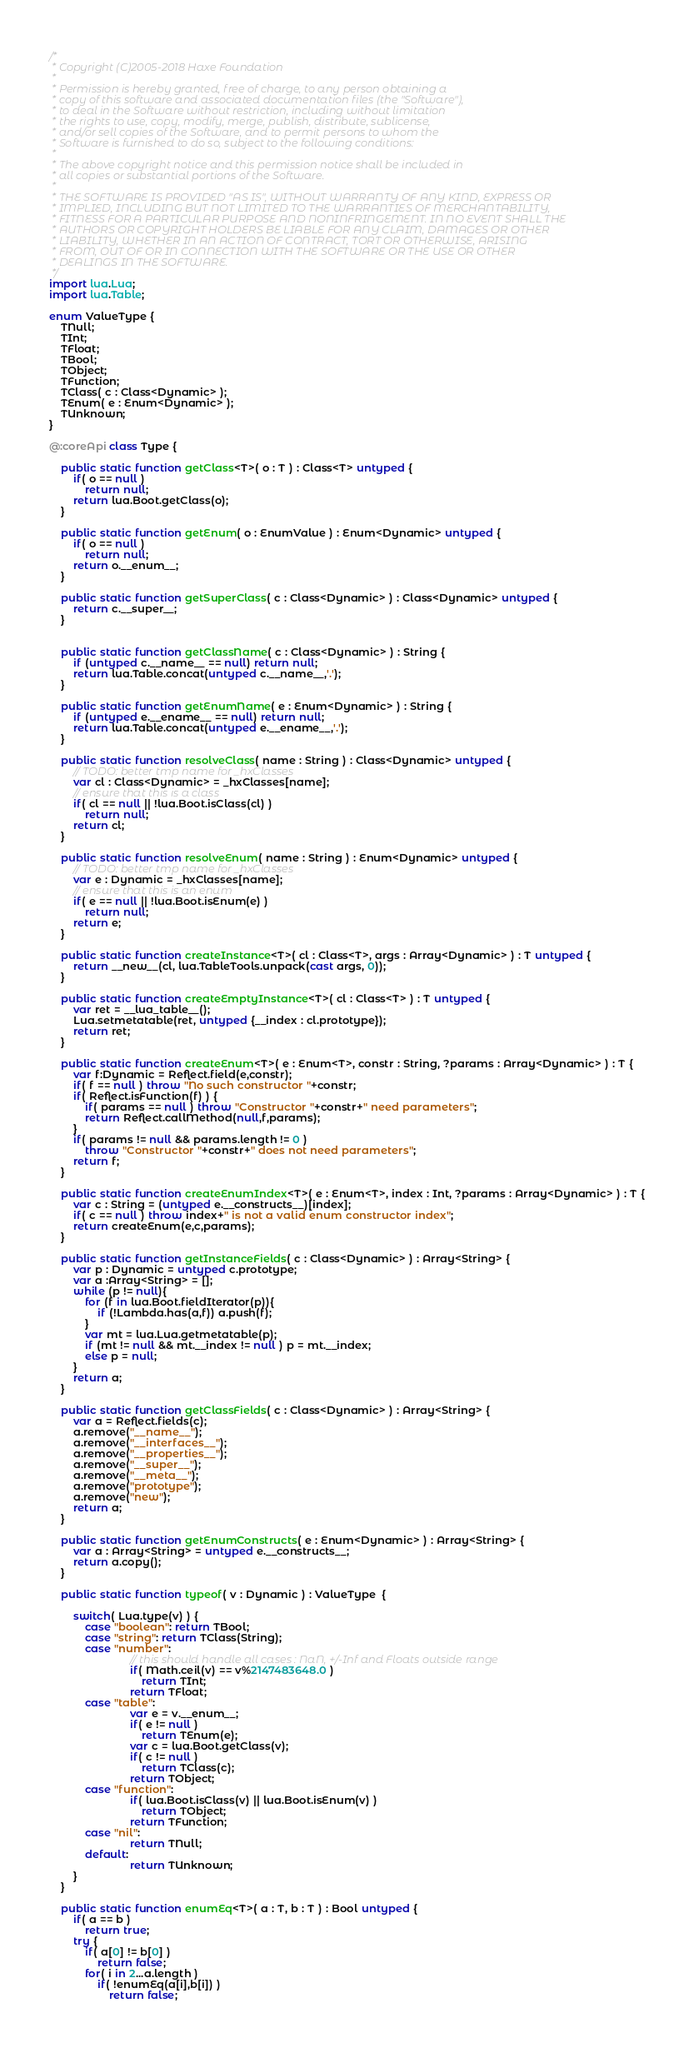<code> <loc_0><loc_0><loc_500><loc_500><_Haxe_>/*
 * Copyright (C)2005-2018 Haxe Foundation
 *
 * Permission is hereby granted, free of charge, to any person obtaining a
 * copy of this software and associated documentation files (the "Software"),
 * to deal in the Software without restriction, including without limitation
 * the rights to use, copy, modify, merge, publish, distribute, sublicense,
 * and/or sell copies of the Software, and to permit persons to whom the
 * Software is furnished to do so, subject to the following conditions:
 *
 * The above copyright notice and this permission notice shall be included in
 * all copies or substantial portions of the Software.
 *
 * THE SOFTWARE IS PROVIDED "AS IS", WITHOUT WARRANTY OF ANY KIND, EXPRESS OR
 * IMPLIED, INCLUDING BUT NOT LIMITED TO THE WARRANTIES OF MERCHANTABILITY,
 * FITNESS FOR A PARTICULAR PURPOSE AND NONINFRINGEMENT. IN NO EVENT SHALL THE
 * AUTHORS OR COPYRIGHT HOLDERS BE LIABLE FOR ANY CLAIM, DAMAGES OR OTHER
 * LIABILITY, WHETHER IN AN ACTION OF CONTRACT, TORT OR OTHERWISE, ARISING
 * FROM, OUT OF OR IN CONNECTION WITH THE SOFTWARE OR THE USE OR OTHER
 * DEALINGS IN THE SOFTWARE.
 */
import lua.Lua;
import lua.Table;

enum ValueType {
	TNull;
	TInt;
	TFloat;
	TBool;
	TObject;
	TFunction;
	TClass( c : Class<Dynamic> );
	TEnum( e : Enum<Dynamic> );
	TUnknown;
}

@:coreApi class Type {

	public static function getClass<T>( o : T ) : Class<T> untyped {
		if( o == null )
			return null;
		return lua.Boot.getClass(o);
	}

	public static function getEnum( o : EnumValue ) : Enum<Dynamic> untyped {
		if( o == null )
			return null;
		return o.__enum__;
	}

	public static function getSuperClass( c : Class<Dynamic> ) : Class<Dynamic> untyped {
		return c.__super__;
	}


	public static function getClassName( c : Class<Dynamic> ) : String {
		if (untyped c.__name__ == null) return null;
		return lua.Table.concat(untyped c.__name__,'.');
	}

	public static function getEnumName( e : Enum<Dynamic> ) : String {
		if (untyped e.__ename__ == null) return null;
		return lua.Table.concat(untyped e.__ename__,'.');
	}

	public static function resolveClass( name : String ) : Class<Dynamic> untyped {
		// TODO: better tmp name for _hxClasses
		var cl : Class<Dynamic> = _hxClasses[name];
		// ensure that this is a class
		if( cl == null || !lua.Boot.isClass(cl) )
			return null;
		return cl;
	}

	public static function resolveEnum( name : String ) : Enum<Dynamic> untyped {
		// TODO: better tmp name for _hxClasses
		var e : Dynamic = _hxClasses[name];
		// ensure that this is an enum
		if( e == null || !lua.Boot.isEnum(e) )
			return null;
		return e;
	}

	public static function createInstance<T>( cl : Class<T>, args : Array<Dynamic> ) : T untyped {
		return __new__(cl, lua.TableTools.unpack(cast args, 0));
	}

	public static function createEmptyInstance<T>( cl : Class<T> ) : T untyped {
		var ret = __lua_table__();
		Lua.setmetatable(ret, untyped {__index : cl.prototype});
		return ret;
	}

	public static function createEnum<T>( e : Enum<T>, constr : String, ?params : Array<Dynamic> ) : T {
		var f:Dynamic = Reflect.field(e,constr);
		if( f == null ) throw "No such constructor "+constr;
		if( Reflect.isFunction(f) ) {
			if( params == null ) throw "Constructor "+constr+" need parameters";
			return Reflect.callMethod(null,f,params);
		}
		if( params != null && params.length != 0 )
			throw "Constructor "+constr+" does not need parameters";
		return f;
	}

	public static function createEnumIndex<T>( e : Enum<T>, index : Int, ?params : Array<Dynamic> ) : T {
		var c : String = (untyped e.__constructs__)[index];
		if( c == null ) throw index+" is not a valid enum constructor index";
		return createEnum(e,c,params);
	}

	public static function getInstanceFields( c : Class<Dynamic> ) : Array<String> {
		var p : Dynamic = untyped c.prototype;
		var a :Array<String> = [];
		while (p != null){
			for (f in lua.Boot.fieldIterator(p)){
				if (!Lambda.has(a,f)) a.push(f);
			}
			var mt = lua.Lua.getmetatable(p);
			if (mt != null && mt.__index != null ) p = mt.__index;
			else p = null;
		}
		return a;
	}

	public static function getClassFields( c : Class<Dynamic> ) : Array<String> {
		var a = Reflect.fields(c);
		a.remove("__name__");
		a.remove("__interfaces__");
		a.remove("__properties__");
		a.remove("__super__");
		a.remove("__meta__");
		a.remove("prototype");
		a.remove("new");
		return a;
	}

	public static function getEnumConstructs( e : Enum<Dynamic> ) : Array<String> {
		var a : Array<String> = untyped e.__constructs__;
		return a.copy();
	}

	public static function typeof( v : Dynamic ) : ValueType  {

		switch( Lua.type(v) ) {
			case "boolean": return TBool;
			case "string": return TClass(String);
			case "number":
						   // this should handle all cases : NaN, +/-Inf and Floats outside range
						   if( Math.ceil(v) == v%2147483648.0 )
							   return TInt;
						   return TFloat;
			case "table":
						   var e = v.__enum__;
						   if( e != null )
							   return TEnum(e);
						   var c = lua.Boot.getClass(v);
						   if( c != null )
							   return TClass(c);
						   return TObject;
			case "function":
						   if( lua.Boot.isClass(v) || lua.Boot.isEnum(v) )
							   return TObject;
						   return TFunction;
			case "nil":
						   return TNull;
			default:
						   return TUnknown;
		}
	}

	public static function enumEq<T>( a : T, b : T ) : Bool untyped {
		if( a == b )
			return true;
		try {
			if( a[0] != b[0] )
				return false;
			for( i in 2...a.length )
				if( !enumEq(a[i],b[i]) )
					return false;</code> 